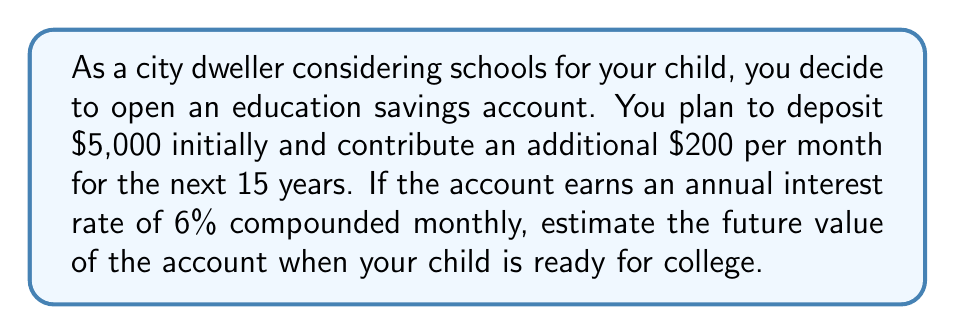Show me your answer to this math problem. To solve this problem, we need to use the compound interest formula for both the initial deposit and the regular monthly contributions.

1. For the initial deposit:
   We'll use the compound interest formula:
   $$A = P(1 + \frac{r}{n})^{nt}$$
   Where:
   $A$ = final amount
   $P$ = principal (initial deposit)
   $r$ = annual interest rate (as a decimal)
   $n$ = number of times interest is compounded per year
   $t$ = number of years

   $$A_1 = 5000(1 + \frac{0.06}{12})^{12 \times 15} = 5000(1.005)^{180} \approx 12,096.94$$

2. For the monthly contributions:
   We'll use the future value of an annuity formula:
   $$A = PMT \times \frac{(1 + \frac{r}{n})^{nt} - 1}{\frac{r}{n}}$$
   Where:
   $PMT$ = regular payment amount

   $$A_2 = 200 \times \frac{(1 + \frac{0.06}{12})^{12 \times 15} - 1}{\frac{0.06}{12}} \approx 56,612.65$$

3. To get the total future value, we add the results from steps 1 and 2:
   $$\text{Total Future Value} = A_1 + A_2 = 12,096.94 + 56,612.65 = 68,709.59$$
Answer: The estimated future value of the education savings account after 15 years is approximately $68,709.59. 